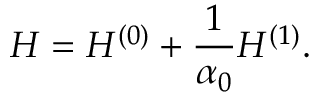<formula> <loc_0><loc_0><loc_500><loc_500>H = H ^ { ( 0 ) } + \frac { 1 } { \alpha _ { 0 } } H ^ { ( 1 ) } .</formula> 